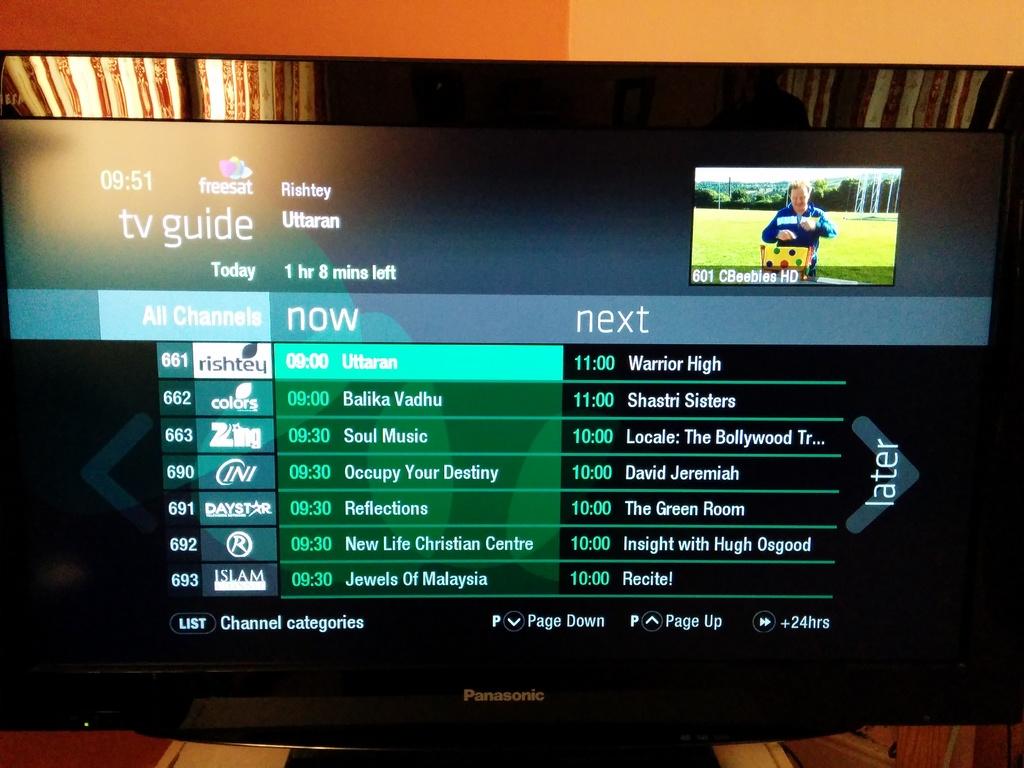What is on after reflections?
Give a very brief answer. The green room. What kind of guide is this?
Offer a terse response. Tv. 